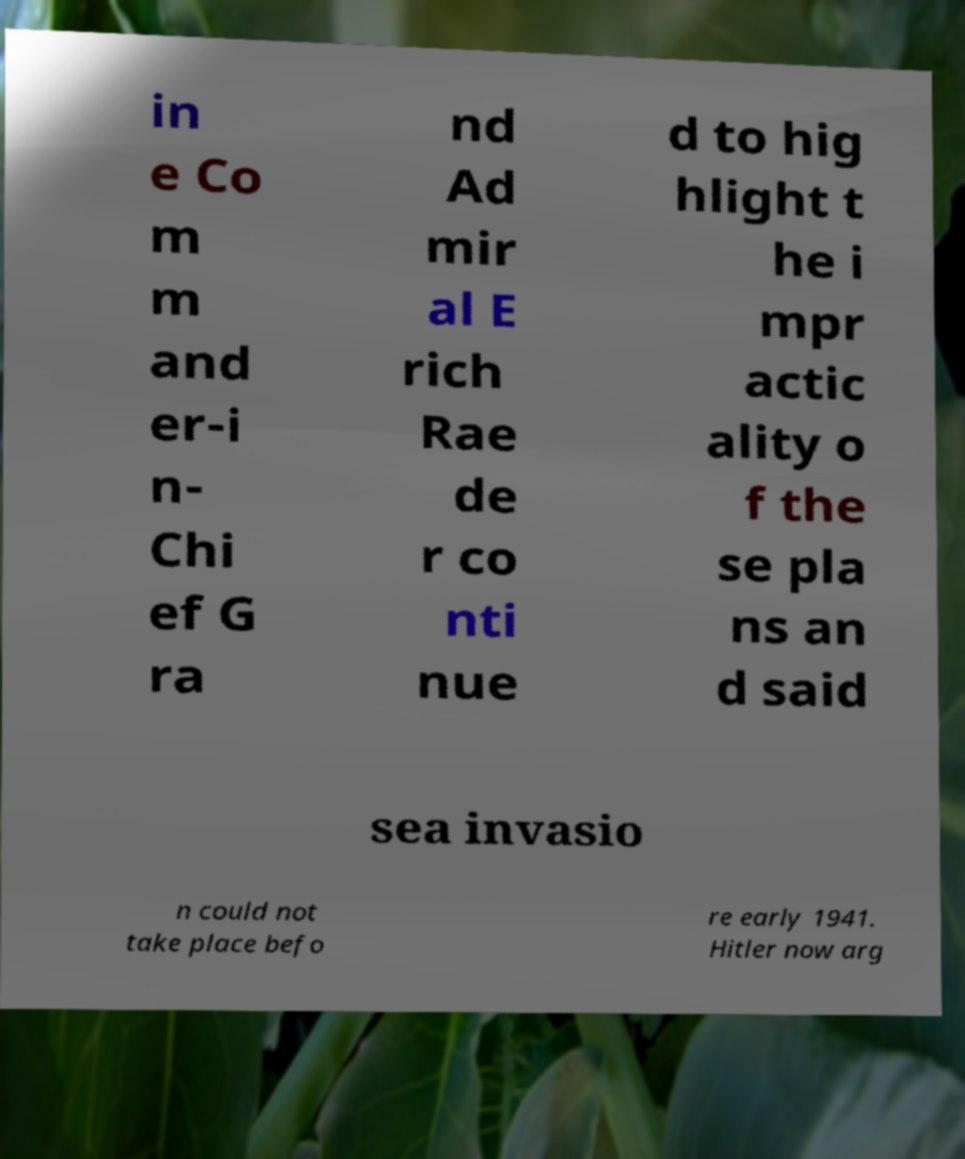Could you assist in decoding the text presented in this image and type it out clearly? in e Co m m and er-i n- Chi ef G ra nd Ad mir al E rich Rae de r co nti nue d to hig hlight t he i mpr actic ality o f the se pla ns an d said sea invasio n could not take place befo re early 1941. Hitler now arg 